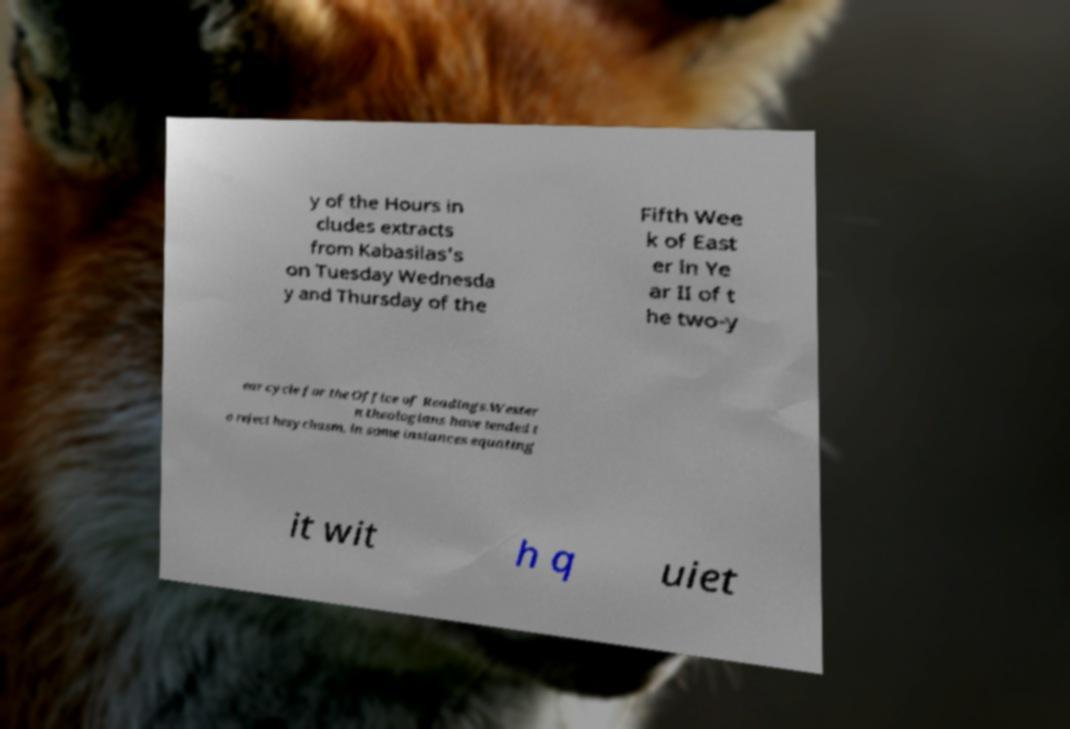I need the written content from this picture converted into text. Can you do that? y of the Hours in cludes extracts from Kabasilas's on Tuesday Wednesda y and Thursday of the Fifth Wee k of East er in Ye ar II of t he two-y ear cycle for the Office of Readings.Wester n theologians have tended t o reject hesychasm, in some instances equating it wit h q uiet 